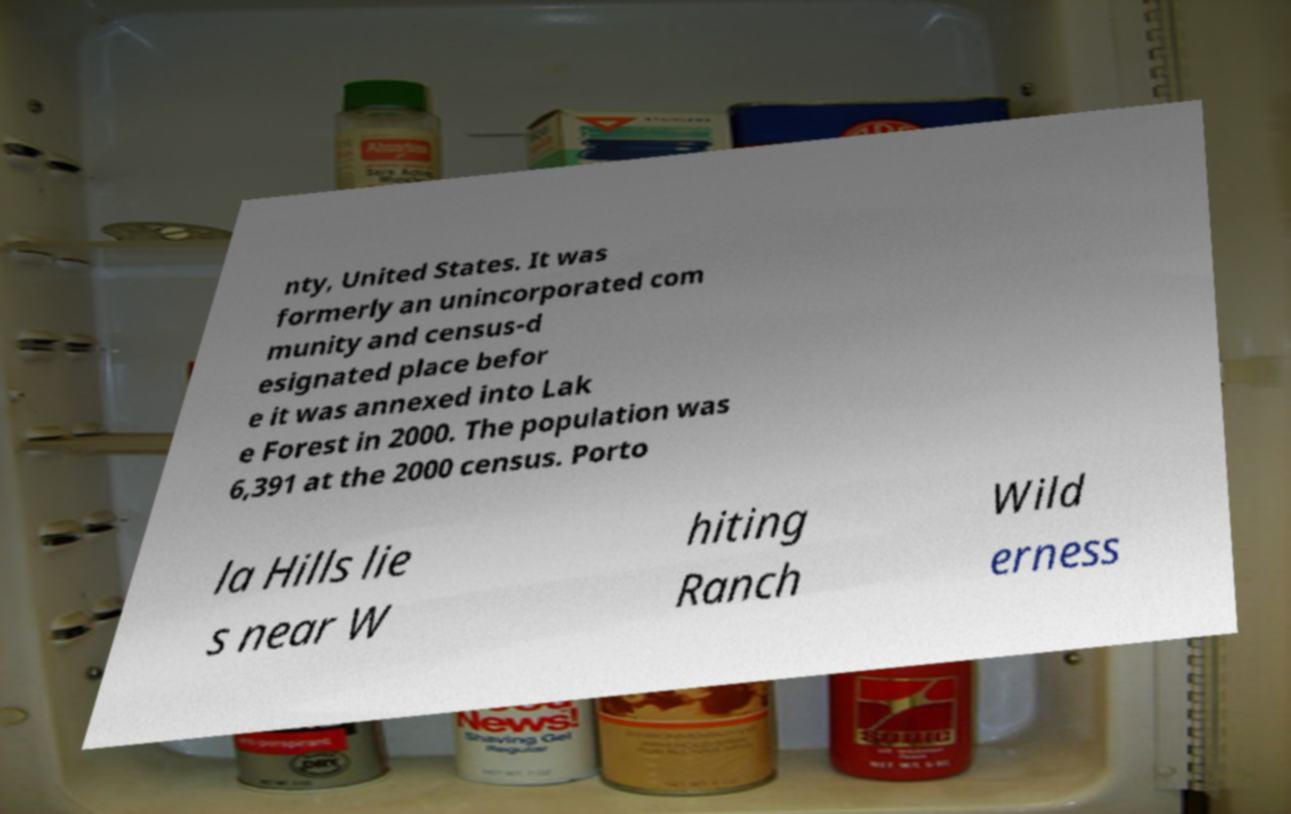Can you accurately transcribe the text from the provided image for me? nty, United States. It was formerly an unincorporated com munity and census-d esignated place befor e it was annexed into Lak e Forest in 2000. The population was 6,391 at the 2000 census. Porto la Hills lie s near W hiting Ranch Wild erness 